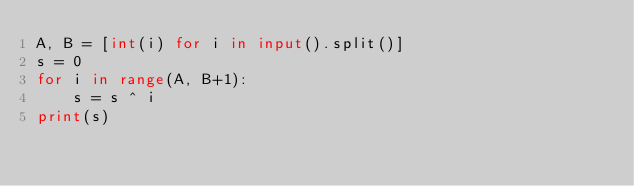<code> <loc_0><loc_0><loc_500><loc_500><_Python_>A, B = [int(i) for i in input().split()]
s = 0
for i in range(A, B+1):
    s = s ^ i
print(s)
</code> 